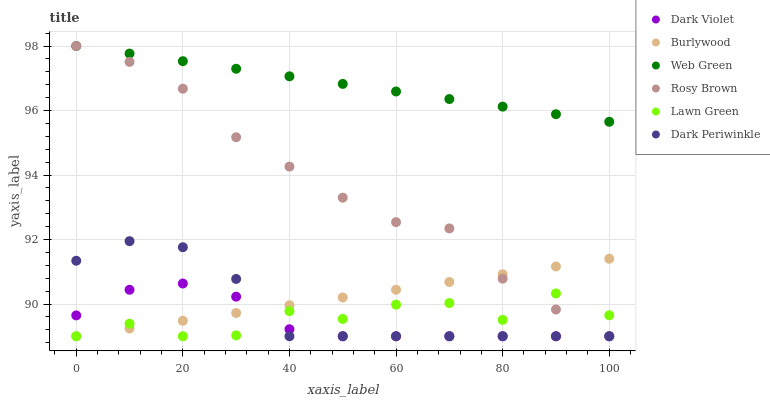Does Dark Violet have the minimum area under the curve?
Answer yes or no. Yes. Does Web Green have the maximum area under the curve?
Answer yes or no. Yes. Does Burlywood have the minimum area under the curve?
Answer yes or no. No. Does Burlywood have the maximum area under the curve?
Answer yes or no. No. Is Web Green the smoothest?
Answer yes or no. Yes. Is Lawn Green the roughest?
Answer yes or no. Yes. Is Burlywood the smoothest?
Answer yes or no. No. Is Burlywood the roughest?
Answer yes or no. No. Does Lawn Green have the lowest value?
Answer yes or no. Yes. Does Web Green have the lowest value?
Answer yes or no. No. Does Web Green have the highest value?
Answer yes or no. Yes. Does Burlywood have the highest value?
Answer yes or no. No. Is Burlywood less than Web Green?
Answer yes or no. Yes. Is Web Green greater than Dark Violet?
Answer yes or no. Yes. Does Dark Violet intersect Lawn Green?
Answer yes or no. Yes. Is Dark Violet less than Lawn Green?
Answer yes or no. No. Is Dark Violet greater than Lawn Green?
Answer yes or no. No. Does Burlywood intersect Web Green?
Answer yes or no. No. 